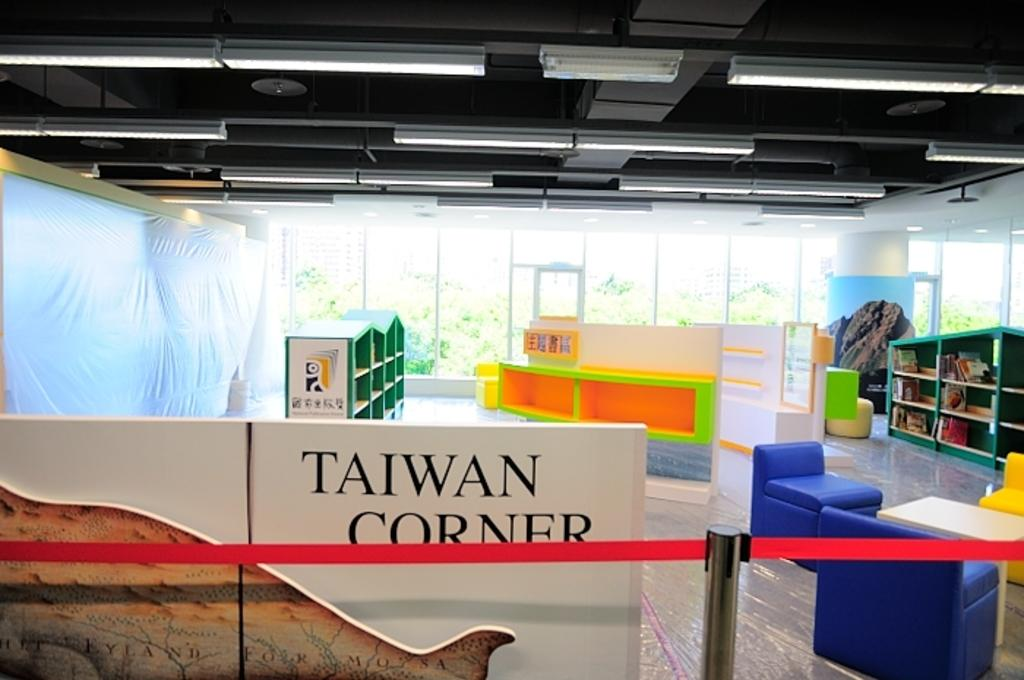<image>
Offer a succinct explanation of the picture presented. A corner of a library focuses on Taiwan. 